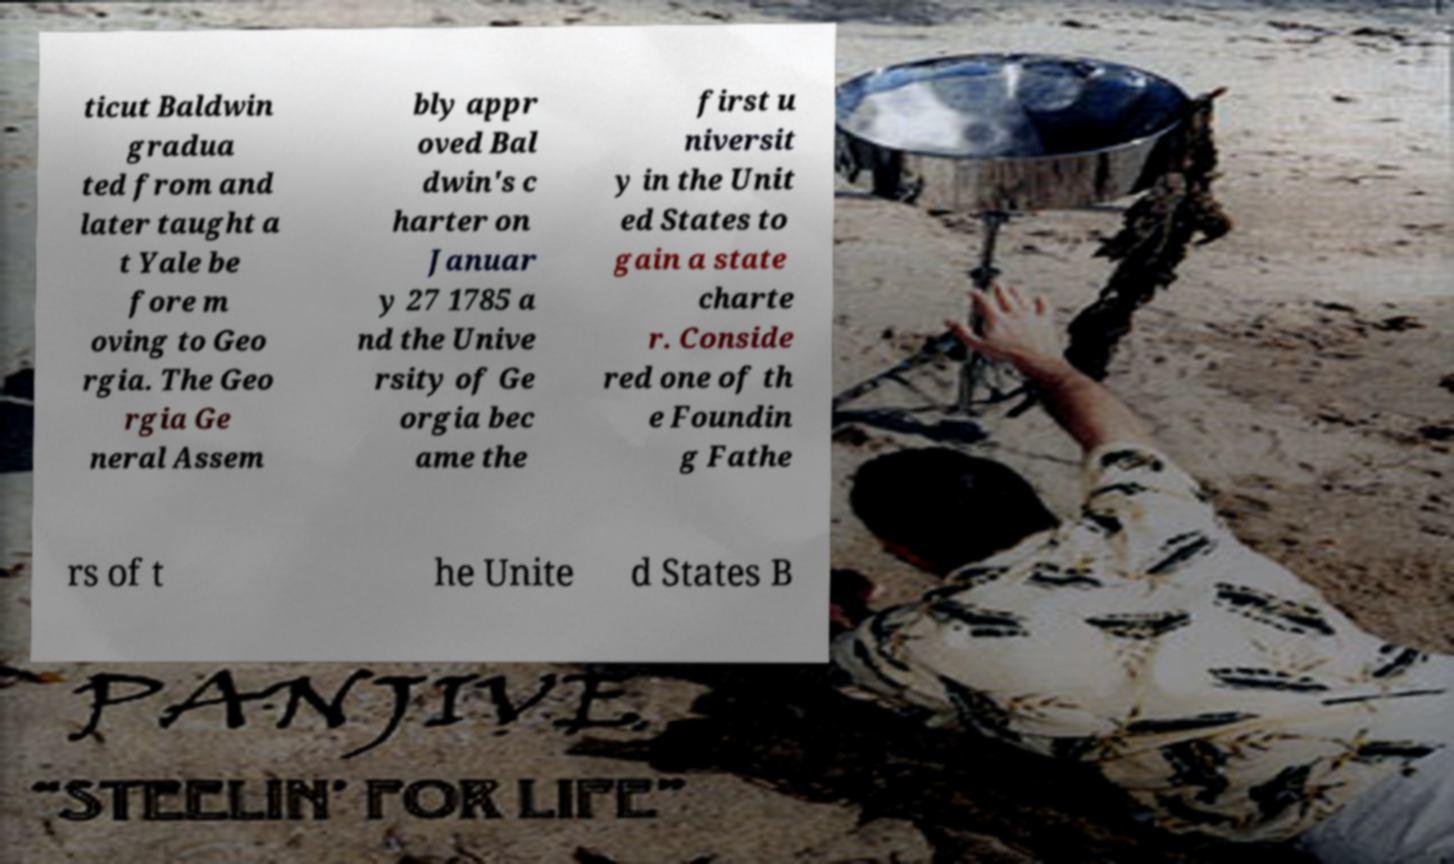Please identify and transcribe the text found in this image. ticut Baldwin gradua ted from and later taught a t Yale be fore m oving to Geo rgia. The Geo rgia Ge neral Assem bly appr oved Bal dwin's c harter on Januar y 27 1785 a nd the Unive rsity of Ge orgia bec ame the first u niversit y in the Unit ed States to gain a state charte r. Conside red one of th e Foundin g Fathe rs of t he Unite d States B 